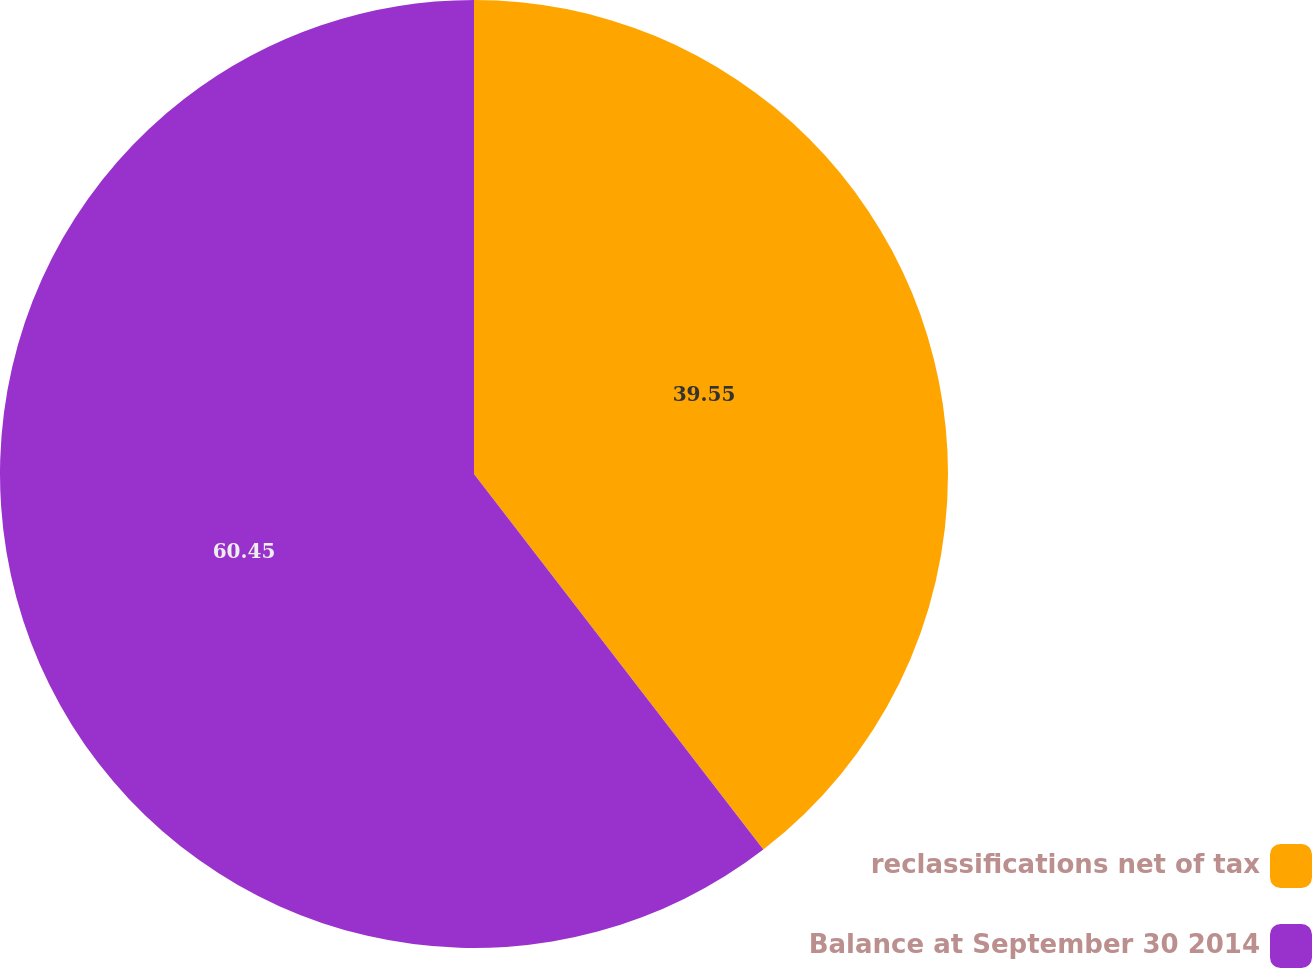<chart> <loc_0><loc_0><loc_500><loc_500><pie_chart><fcel>reclassifications net of tax<fcel>Balance at September 30 2014<nl><fcel>39.55%<fcel>60.45%<nl></chart> 